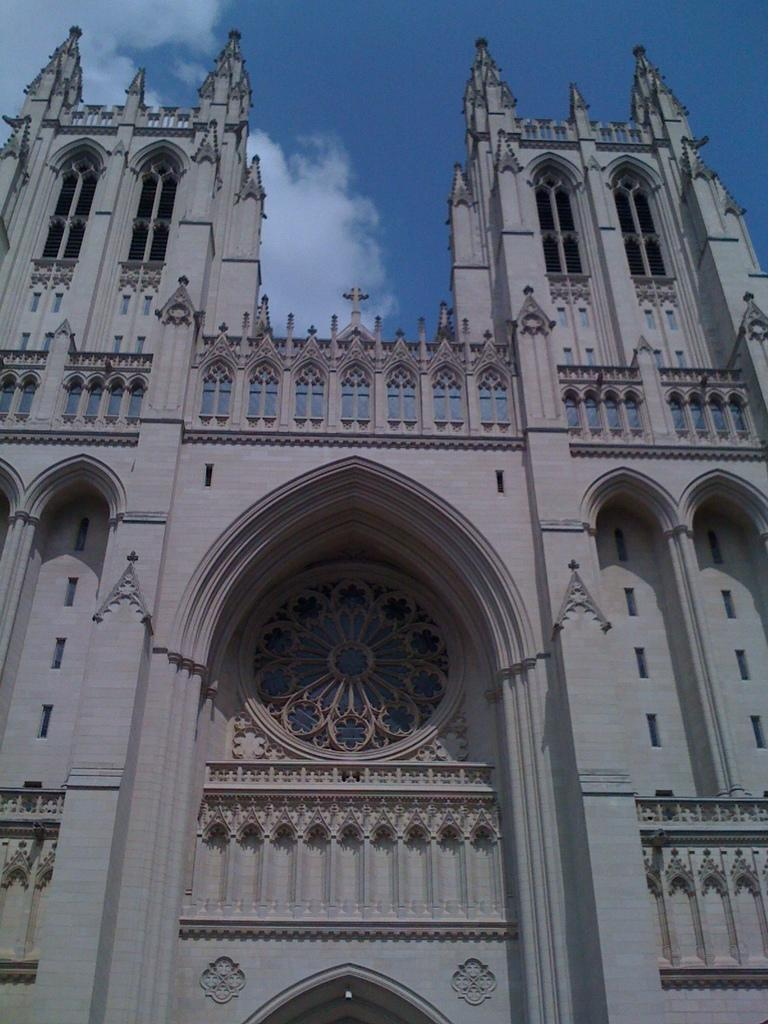What is the color of the building in the picture? The building in the picture is white. What features can be observed on the building? The building has windows. What can be seen in the background of the picture? The sky is visible in the background of the picture. Can you see any feathers floating in the air near the building? There are no feathers visible in the image; it only features a white building with windows and a sky background. 